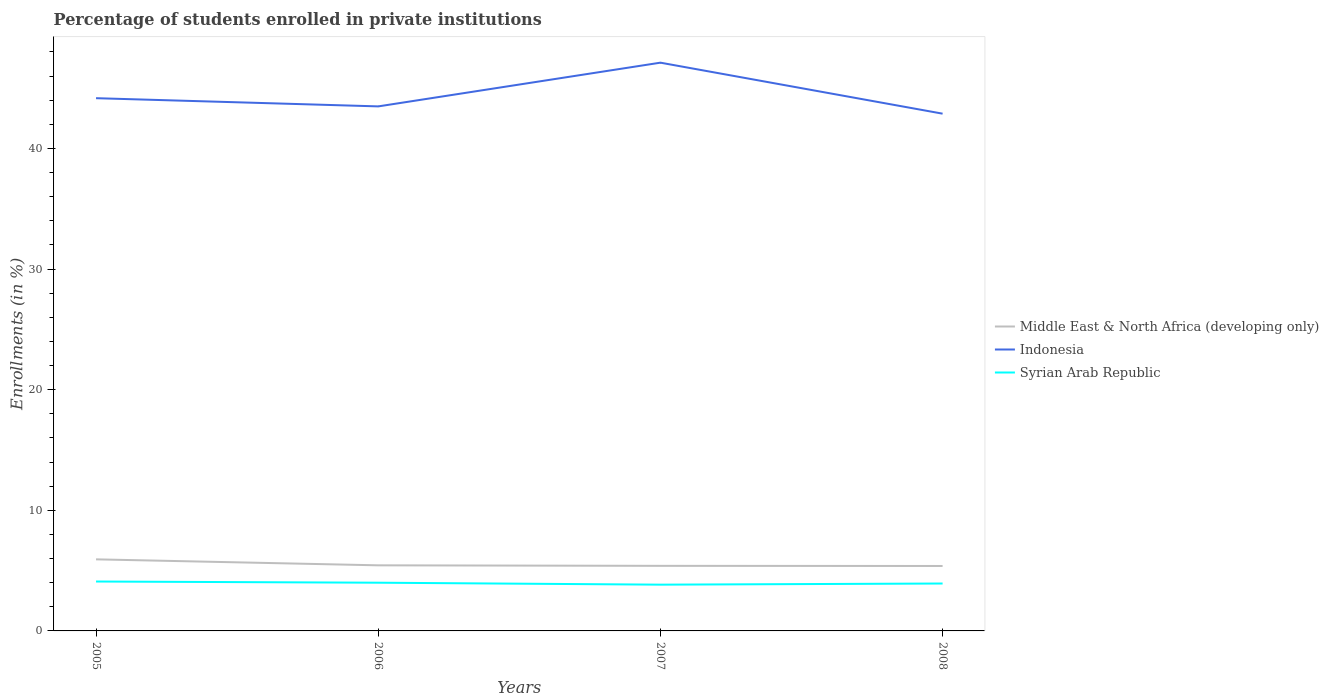How many different coloured lines are there?
Give a very brief answer. 3. Does the line corresponding to Middle East & North Africa (developing only) intersect with the line corresponding to Indonesia?
Offer a very short reply. No. Across all years, what is the maximum percentage of trained teachers in Middle East & North Africa (developing only)?
Your answer should be very brief. 5.38. In which year was the percentage of trained teachers in Middle East & North Africa (developing only) maximum?
Give a very brief answer. 2008. What is the total percentage of trained teachers in Syrian Arab Republic in the graph?
Provide a succinct answer. 0.17. What is the difference between the highest and the second highest percentage of trained teachers in Indonesia?
Provide a succinct answer. 4.23. What is the difference between the highest and the lowest percentage of trained teachers in Indonesia?
Your response must be concise. 1. What is the difference between two consecutive major ticks on the Y-axis?
Ensure brevity in your answer.  10. Are the values on the major ticks of Y-axis written in scientific E-notation?
Give a very brief answer. No. Where does the legend appear in the graph?
Offer a very short reply. Center right. How many legend labels are there?
Offer a terse response. 3. What is the title of the graph?
Your answer should be very brief. Percentage of students enrolled in private institutions. What is the label or title of the Y-axis?
Your answer should be very brief. Enrollments (in %). What is the Enrollments (in %) of Middle East & North Africa (developing only) in 2005?
Offer a terse response. 5.93. What is the Enrollments (in %) of Indonesia in 2005?
Your answer should be compact. 44.17. What is the Enrollments (in %) of Syrian Arab Republic in 2005?
Provide a succinct answer. 4.1. What is the Enrollments (in %) in Middle East & North Africa (developing only) in 2006?
Offer a very short reply. 5.44. What is the Enrollments (in %) of Indonesia in 2006?
Offer a very short reply. 43.49. What is the Enrollments (in %) in Syrian Arab Republic in 2006?
Make the answer very short. 4. What is the Enrollments (in %) in Middle East & North Africa (developing only) in 2007?
Offer a very short reply. 5.39. What is the Enrollments (in %) in Indonesia in 2007?
Your response must be concise. 47.11. What is the Enrollments (in %) of Syrian Arab Republic in 2007?
Keep it short and to the point. 3.84. What is the Enrollments (in %) in Middle East & North Africa (developing only) in 2008?
Make the answer very short. 5.38. What is the Enrollments (in %) in Indonesia in 2008?
Your answer should be very brief. 42.89. What is the Enrollments (in %) in Syrian Arab Republic in 2008?
Offer a very short reply. 3.93. Across all years, what is the maximum Enrollments (in %) in Middle East & North Africa (developing only)?
Provide a short and direct response. 5.93. Across all years, what is the maximum Enrollments (in %) in Indonesia?
Give a very brief answer. 47.11. Across all years, what is the maximum Enrollments (in %) in Syrian Arab Republic?
Your answer should be very brief. 4.1. Across all years, what is the minimum Enrollments (in %) of Middle East & North Africa (developing only)?
Ensure brevity in your answer.  5.38. Across all years, what is the minimum Enrollments (in %) of Indonesia?
Offer a very short reply. 42.89. Across all years, what is the minimum Enrollments (in %) in Syrian Arab Republic?
Give a very brief answer. 3.84. What is the total Enrollments (in %) of Middle East & North Africa (developing only) in the graph?
Ensure brevity in your answer.  22.15. What is the total Enrollments (in %) of Indonesia in the graph?
Keep it short and to the point. 177.66. What is the total Enrollments (in %) of Syrian Arab Republic in the graph?
Your response must be concise. 15.86. What is the difference between the Enrollments (in %) in Middle East & North Africa (developing only) in 2005 and that in 2006?
Make the answer very short. 0.5. What is the difference between the Enrollments (in %) in Indonesia in 2005 and that in 2006?
Offer a terse response. 0.68. What is the difference between the Enrollments (in %) of Syrian Arab Republic in 2005 and that in 2006?
Provide a short and direct response. 0.1. What is the difference between the Enrollments (in %) of Middle East & North Africa (developing only) in 2005 and that in 2007?
Ensure brevity in your answer.  0.54. What is the difference between the Enrollments (in %) of Indonesia in 2005 and that in 2007?
Offer a terse response. -2.94. What is the difference between the Enrollments (in %) in Syrian Arab Republic in 2005 and that in 2007?
Your answer should be very brief. 0.26. What is the difference between the Enrollments (in %) of Middle East & North Africa (developing only) in 2005 and that in 2008?
Your response must be concise. 0.55. What is the difference between the Enrollments (in %) of Indonesia in 2005 and that in 2008?
Your answer should be very brief. 1.28. What is the difference between the Enrollments (in %) of Syrian Arab Republic in 2005 and that in 2008?
Keep it short and to the point. 0.17. What is the difference between the Enrollments (in %) in Middle East & North Africa (developing only) in 2006 and that in 2007?
Give a very brief answer. 0.04. What is the difference between the Enrollments (in %) in Indonesia in 2006 and that in 2007?
Your answer should be very brief. -3.62. What is the difference between the Enrollments (in %) in Syrian Arab Republic in 2006 and that in 2007?
Keep it short and to the point. 0.16. What is the difference between the Enrollments (in %) of Middle East & North Africa (developing only) in 2006 and that in 2008?
Keep it short and to the point. 0.05. What is the difference between the Enrollments (in %) in Indonesia in 2006 and that in 2008?
Offer a terse response. 0.6. What is the difference between the Enrollments (in %) of Syrian Arab Republic in 2006 and that in 2008?
Ensure brevity in your answer.  0.07. What is the difference between the Enrollments (in %) in Middle East & North Africa (developing only) in 2007 and that in 2008?
Provide a short and direct response. 0.01. What is the difference between the Enrollments (in %) of Indonesia in 2007 and that in 2008?
Give a very brief answer. 4.23. What is the difference between the Enrollments (in %) in Syrian Arab Republic in 2007 and that in 2008?
Provide a short and direct response. -0.09. What is the difference between the Enrollments (in %) of Middle East & North Africa (developing only) in 2005 and the Enrollments (in %) of Indonesia in 2006?
Offer a very short reply. -37.55. What is the difference between the Enrollments (in %) of Middle East & North Africa (developing only) in 2005 and the Enrollments (in %) of Syrian Arab Republic in 2006?
Ensure brevity in your answer.  1.94. What is the difference between the Enrollments (in %) in Indonesia in 2005 and the Enrollments (in %) in Syrian Arab Republic in 2006?
Ensure brevity in your answer.  40.17. What is the difference between the Enrollments (in %) of Middle East & North Africa (developing only) in 2005 and the Enrollments (in %) of Indonesia in 2007?
Offer a very short reply. -41.18. What is the difference between the Enrollments (in %) of Middle East & North Africa (developing only) in 2005 and the Enrollments (in %) of Syrian Arab Republic in 2007?
Ensure brevity in your answer.  2.1. What is the difference between the Enrollments (in %) of Indonesia in 2005 and the Enrollments (in %) of Syrian Arab Republic in 2007?
Provide a succinct answer. 40.33. What is the difference between the Enrollments (in %) of Middle East & North Africa (developing only) in 2005 and the Enrollments (in %) of Indonesia in 2008?
Make the answer very short. -36.95. What is the difference between the Enrollments (in %) in Middle East & North Africa (developing only) in 2005 and the Enrollments (in %) in Syrian Arab Republic in 2008?
Offer a terse response. 2. What is the difference between the Enrollments (in %) of Indonesia in 2005 and the Enrollments (in %) of Syrian Arab Republic in 2008?
Your answer should be very brief. 40.24. What is the difference between the Enrollments (in %) in Middle East & North Africa (developing only) in 2006 and the Enrollments (in %) in Indonesia in 2007?
Your response must be concise. -41.68. What is the difference between the Enrollments (in %) of Middle East & North Africa (developing only) in 2006 and the Enrollments (in %) of Syrian Arab Republic in 2007?
Make the answer very short. 1.6. What is the difference between the Enrollments (in %) in Indonesia in 2006 and the Enrollments (in %) in Syrian Arab Republic in 2007?
Keep it short and to the point. 39.65. What is the difference between the Enrollments (in %) of Middle East & North Africa (developing only) in 2006 and the Enrollments (in %) of Indonesia in 2008?
Your response must be concise. -37.45. What is the difference between the Enrollments (in %) of Middle East & North Africa (developing only) in 2006 and the Enrollments (in %) of Syrian Arab Republic in 2008?
Give a very brief answer. 1.51. What is the difference between the Enrollments (in %) in Indonesia in 2006 and the Enrollments (in %) in Syrian Arab Republic in 2008?
Your answer should be compact. 39.56. What is the difference between the Enrollments (in %) of Middle East & North Africa (developing only) in 2007 and the Enrollments (in %) of Indonesia in 2008?
Make the answer very short. -37.49. What is the difference between the Enrollments (in %) in Middle East & North Africa (developing only) in 2007 and the Enrollments (in %) in Syrian Arab Republic in 2008?
Ensure brevity in your answer.  1.46. What is the difference between the Enrollments (in %) of Indonesia in 2007 and the Enrollments (in %) of Syrian Arab Republic in 2008?
Keep it short and to the point. 43.18. What is the average Enrollments (in %) in Middle East & North Africa (developing only) per year?
Keep it short and to the point. 5.54. What is the average Enrollments (in %) in Indonesia per year?
Make the answer very short. 44.41. What is the average Enrollments (in %) in Syrian Arab Republic per year?
Provide a short and direct response. 3.96. In the year 2005, what is the difference between the Enrollments (in %) of Middle East & North Africa (developing only) and Enrollments (in %) of Indonesia?
Your answer should be very brief. -38.23. In the year 2005, what is the difference between the Enrollments (in %) of Middle East & North Africa (developing only) and Enrollments (in %) of Syrian Arab Republic?
Provide a succinct answer. 1.84. In the year 2005, what is the difference between the Enrollments (in %) in Indonesia and Enrollments (in %) in Syrian Arab Republic?
Your answer should be very brief. 40.07. In the year 2006, what is the difference between the Enrollments (in %) of Middle East & North Africa (developing only) and Enrollments (in %) of Indonesia?
Keep it short and to the point. -38.05. In the year 2006, what is the difference between the Enrollments (in %) of Middle East & North Africa (developing only) and Enrollments (in %) of Syrian Arab Republic?
Make the answer very short. 1.44. In the year 2006, what is the difference between the Enrollments (in %) in Indonesia and Enrollments (in %) in Syrian Arab Republic?
Offer a terse response. 39.49. In the year 2007, what is the difference between the Enrollments (in %) in Middle East & North Africa (developing only) and Enrollments (in %) in Indonesia?
Offer a terse response. -41.72. In the year 2007, what is the difference between the Enrollments (in %) of Middle East & North Africa (developing only) and Enrollments (in %) of Syrian Arab Republic?
Provide a short and direct response. 1.56. In the year 2007, what is the difference between the Enrollments (in %) of Indonesia and Enrollments (in %) of Syrian Arab Republic?
Offer a terse response. 43.28. In the year 2008, what is the difference between the Enrollments (in %) in Middle East & North Africa (developing only) and Enrollments (in %) in Indonesia?
Your response must be concise. -37.5. In the year 2008, what is the difference between the Enrollments (in %) of Middle East & North Africa (developing only) and Enrollments (in %) of Syrian Arab Republic?
Keep it short and to the point. 1.45. In the year 2008, what is the difference between the Enrollments (in %) in Indonesia and Enrollments (in %) in Syrian Arab Republic?
Offer a terse response. 38.96. What is the ratio of the Enrollments (in %) of Middle East & North Africa (developing only) in 2005 to that in 2006?
Ensure brevity in your answer.  1.09. What is the ratio of the Enrollments (in %) of Indonesia in 2005 to that in 2006?
Offer a very short reply. 1.02. What is the ratio of the Enrollments (in %) of Syrian Arab Republic in 2005 to that in 2006?
Keep it short and to the point. 1.02. What is the ratio of the Enrollments (in %) in Indonesia in 2005 to that in 2007?
Make the answer very short. 0.94. What is the ratio of the Enrollments (in %) of Syrian Arab Republic in 2005 to that in 2007?
Provide a succinct answer. 1.07. What is the ratio of the Enrollments (in %) in Middle East & North Africa (developing only) in 2005 to that in 2008?
Provide a short and direct response. 1.1. What is the ratio of the Enrollments (in %) in Indonesia in 2005 to that in 2008?
Offer a terse response. 1.03. What is the ratio of the Enrollments (in %) in Syrian Arab Republic in 2005 to that in 2008?
Make the answer very short. 1.04. What is the ratio of the Enrollments (in %) in Syrian Arab Republic in 2006 to that in 2007?
Your response must be concise. 1.04. What is the ratio of the Enrollments (in %) of Middle East & North Africa (developing only) in 2006 to that in 2008?
Give a very brief answer. 1.01. What is the ratio of the Enrollments (in %) of Indonesia in 2006 to that in 2008?
Your answer should be very brief. 1.01. What is the ratio of the Enrollments (in %) of Syrian Arab Republic in 2006 to that in 2008?
Keep it short and to the point. 1.02. What is the ratio of the Enrollments (in %) of Indonesia in 2007 to that in 2008?
Provide a short and direct response. 1.1. What is the ratio of the Enrollments (in %) of Syrian Arab Republic in 2007 to that in 2008?
Give a very brief answer. 0.98. What is the difference between the highest and the second highest Enrollments (in %) in Middle East & North Africa (developing only)?
Ensure brevity in your answer.  0.5. What is the difference between the highest and the second highest Enrollments (in %) of Indonesia?
Provide a succinct answer. 2.94. What is the difference between the highest and the second highest Enrollments (in %) in Syrian Arab Republic?
Offer a very short reply. 0.1. What is the difference between the highest and the lowest Enrollments (in %) in Middle East & North Africa (developing only)?
Provide a short and direct response. 0.55. What is the difference between the highest and the lowest Enrollments (in %) of Indonesia?
Ensure brevity in your answer.  4.23. What is the difference between the highest and the lowest Enrollments (in %) in Syrian Arab Republic?
Your response must be concise. 0.26. 